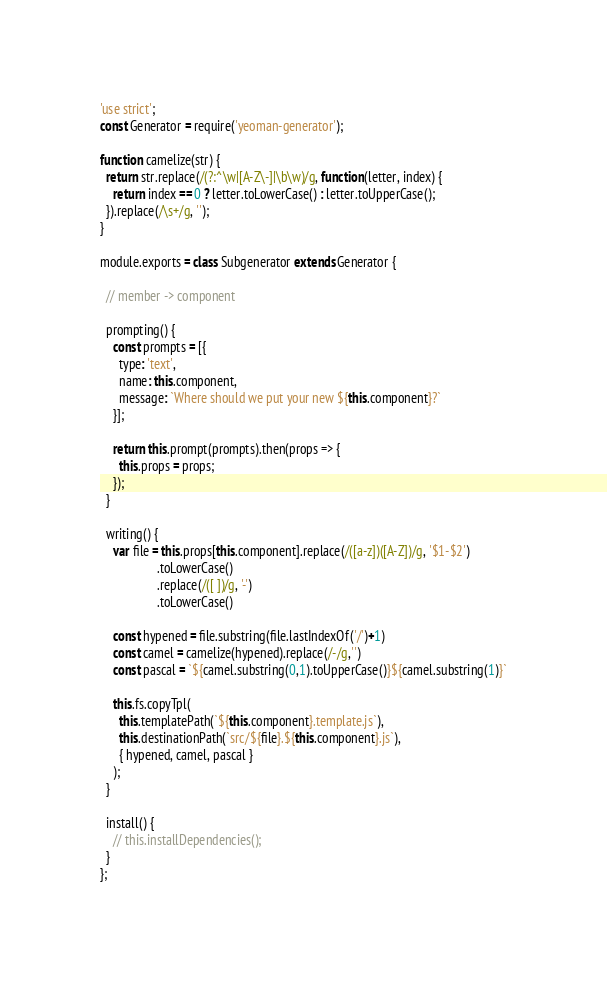<code> <loc_0><loc_0><loc_500><loc_500><_JavaScript_>'use strict';
const Generator = require('yeoman-generator');

function camelize(str) {
  return str.replace(/(?:^\w|[A-Z\-]|\b\w)/g, function(letter, index) {
    return index == 0 ? letter.toLowerCase() : letter.toUpperCase();
  }).replace(/\s+/g, '');
}

module.exports = class Subgenerator extends Generator {

  // member -> component

  prompting() {
    const prompts = [{
      type: 'text',
      name: this.component,
      message: `Where should we put your new ${this.component}?`
    }];

    return this.prompt(prompts).then(props => {
      this.props = props;
    });
  }

  writing() {
    var file = this.props[this.component].replace(/([a-z])([A-Z])/g, '$1-$2')
                  .toLowerCase()
                  .replace(/([ ])/g, '-')
                  .toLowerCase()

    const hypened = file.substring(file.lastIndexOf('/')+1)
    const camel = camelize(hypened).replace(/-/g,'')
    const pascal = `${camel.substring(0,1).toUpperCase()}${camel.substring(1)}`

    this.fs.copyTpl(
      this.templatePath(`${this.component}.template.js`),
      this.destinationPath(`src/${file}.${this.component}.js`),
      { hypened, camel, pascal }
    );
  }

  install() {
    // this.installDependencies();
  }
};
</code> 